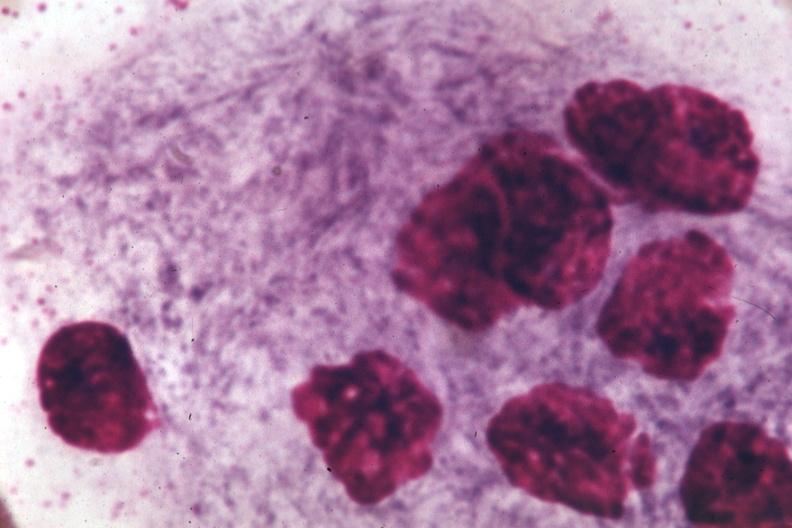what is present?
Answer the question using a single word or phrase. Bone marrow 